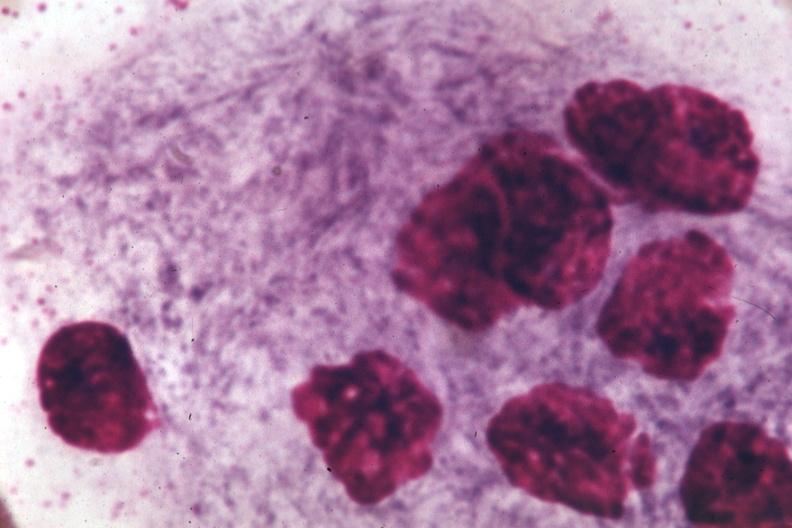what is present?
Answer the question using a single word or phrase. Bone marrow 